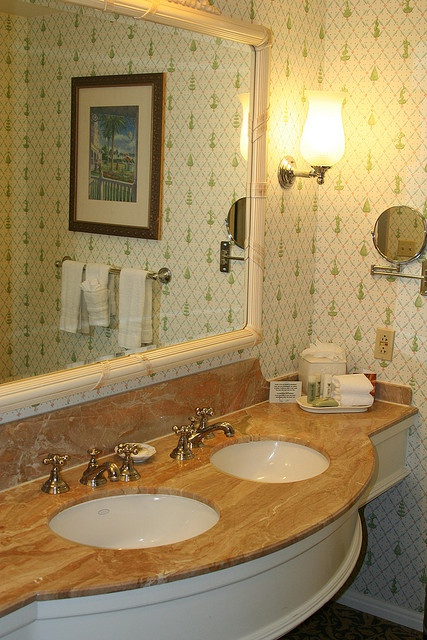Describe the objects in this image and their specific colors. I can see sink in olive and tan tones and sink in olive and tan tones in this image. 